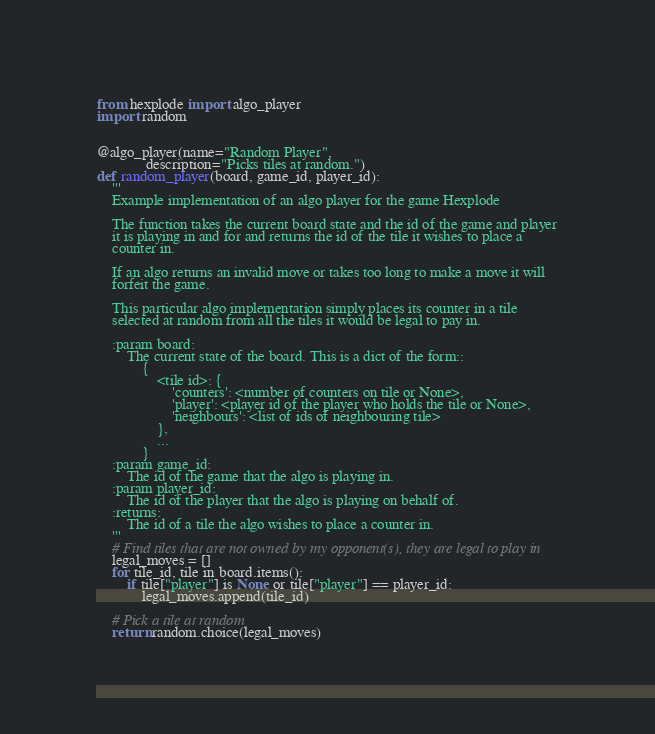Convert code to text. <code><loc_0><loc_0><loc_500><loc_500><_Python_>from hexplode import algo_player
import random


@algo_player(name="Random Player",
             description="Picks tiles at random.")
def random_player(board, game_id, player_id):
    '''
    Example implementation of an algo player for the game Hexplode

    The function takes the current board state and the id of the game and player
    it is playing in and for and returns the id of the tile it wishes to place a
    counter in.

    If an algo returns an invalid move or takes too long to make a move it will
    forfeit the game.

    This particular algo implementation simply places its counter in a tile
    selected at random from all the tiles it would be legal to pay in.

    :param board:
        The current state of the board. This is a dict of the form::
            {
                <tile id>: {
                    'counters': <number of counters on tile or None>,
                    'player': <player id of the player who holds the tile or None>,
                    'neighbours': <list of ids of neighbouring tile>
                },
                ...
            }
    :param game_id:
        The id of the game that the algo is playing in.
    :param player_id:
        The id of the player that the algo is playing on behalf of.
    :returns:
        The id of a tile the algo wishes to place a counter in.
    '''
    # Find tiles that are not owned by my opponent(s), they are legal to play in
    legal_moves = []
    for tile_id, tile in board.items():
        if tile["player"] is None or tile["player"] == player_id:
            legal_moves.append(tile_id)

    # Pick a tile at random
    return random.choice(legal_moves)
</code> 